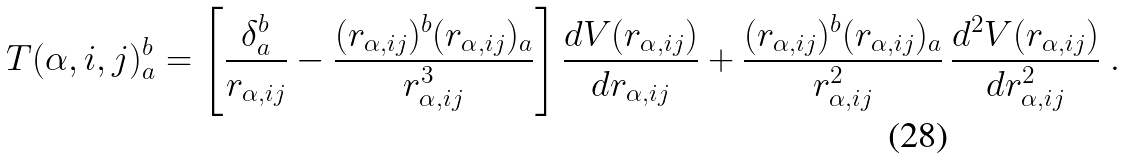Convert formula to latex. <formula><loc_0><loc_0><loc_500><loc_500>T ( \alpha , i , j ) ^ { b } _ { a } = \left [ \frac { \delta _ { a } ^ { b } } { r _ { \alpha , i j } } - \frac { ( r _ { \alpha , i j } ) ^ { b } ( r _ { \alpha , i j } ) _ { a } } { r _ { \alpha , i j } ^ { 3 } } \right ] \frac { d V ( r _ { \alpha , i j } ) } { d r _ { \alpha , i j } } + \frac { ( r _ { \alpha , i j } ) ^ { b } ( r _ { \alpha , i j } ) _ { a } } { r _ { \alpha , i j } ^ { 2 } } \, \frac { d ^ { 2 } V ( r _ { \alpha , i j } ) } { d r _ { \alpha , i j } ^ { 2 } } \ .</formula> 